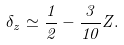Convert formula to latex. <formula><loc_0><loc_0><loc_500><loc_500>\delta _ { z } \simeq \frac { 1 } { 2 } - \frac { 3 } { 1 0 } Z .</formula> 